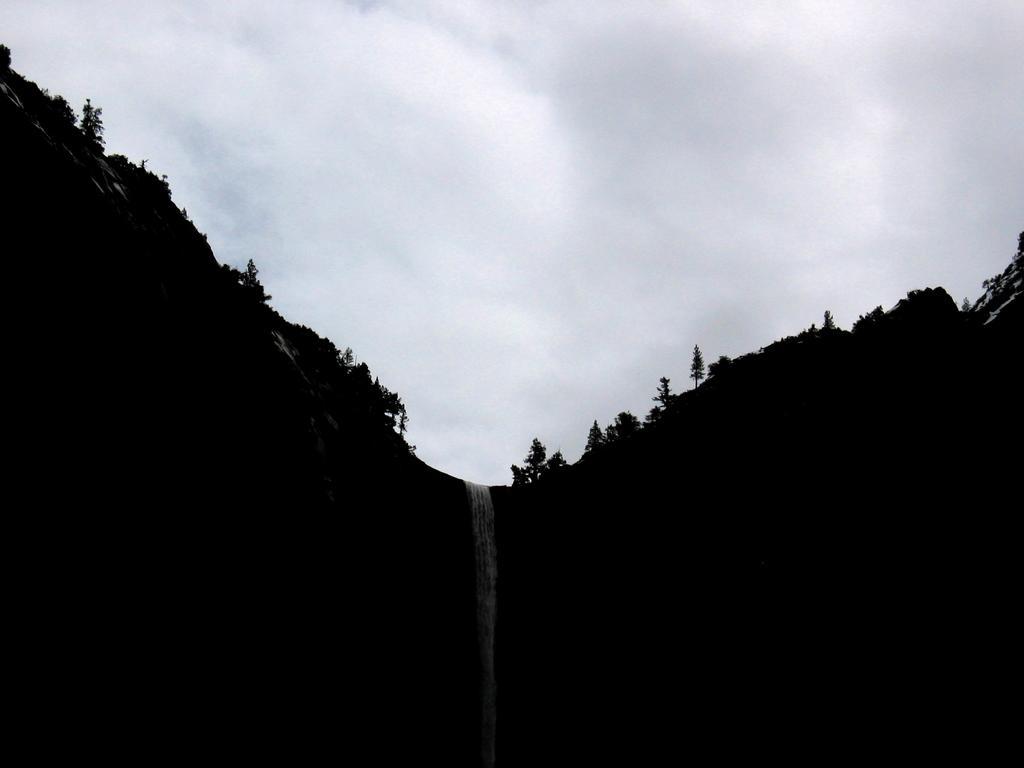Please provide a concise description of this image. In the middle of the picture, we see the waterfalls. On either side of the picture, we see the trees and the hills. In the background, we see the sky. 